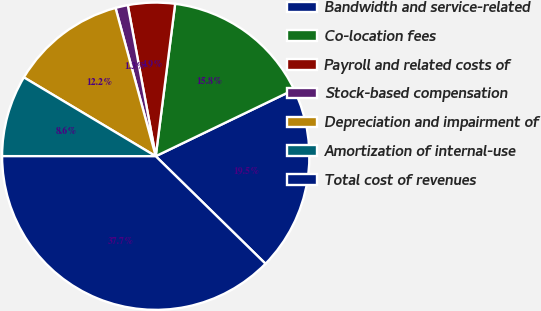Convert chart. <chart><loc_0><loc_0><loc_500><loc_500><pie_chart><fcel>Bandwidth and service-related<fcel>Co-location fees<fcel>Payroll and related costs of<fcel>Stock-based compensation<fcel>Depreciation and impairment of<fcel>Amortization of internal-use<fcel>Total cost of revenues<nl><fcel>19.48%<fcel>15.84%<fcel>4.93%<fcel>1.3%<fcel>12.21%<fcel>8.57%<fcel>37.67%<nl></chart> 